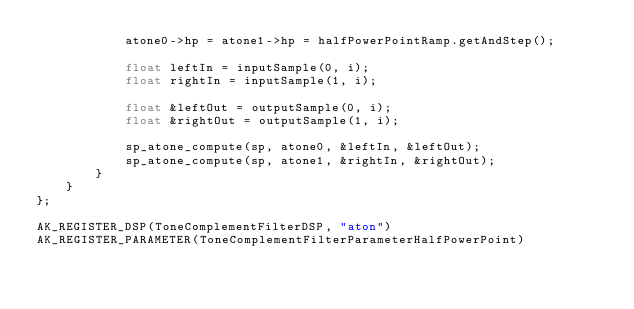Convert code to text. <code><loc_0><loc_0><loc_500><loc_500><_ObjectiveC_>            atone0->hp = atone1->hp = halfPowerPointRamp.getAndStep();

            float leftIn = inputSample(0, i);
            float rightIn = inputSample(1, i);

            float &leftOut = outputSample(0, i);
            float &rightOut = outputSample(1, i);

            sp_atone_compute(sp, atone0, &leftIn, &leftOut);
            sp_atone_compute(sp, atone1, &rightIn, &rightOut);
        }
    }
};

AK_REGISTER_DSP(ToneComplementFilterDSP, "aton")
AK_REGISTER_PARAMETER(ToneComplementFilterParameterHalfPowerPoint)
</code> 